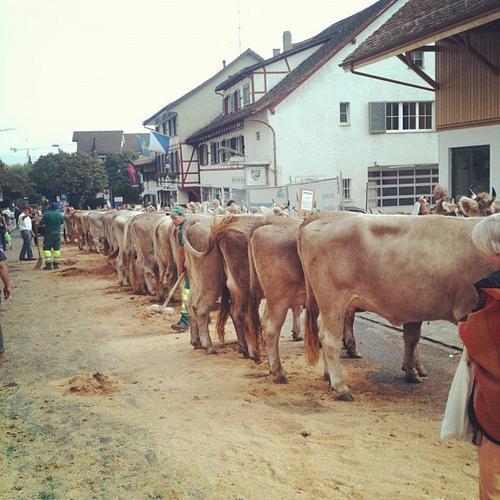How many cows are there?
Give a very brief answer. 12. How many people are wearing green jackets?
Give a very brief answer. 1. 